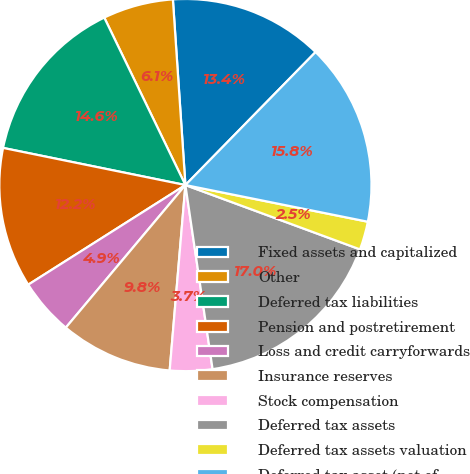Convert chart. <chart><loc_0><loc_0><loc_500><loc_500><pie_chart><fcel>Fixed assets and capitalized<fcel>Other<fcel>Deferred tax liabilities<fcel>Pension and postretirement<fcel>Loss and credit carryforwards<fcel>Insurance reserves<fcel>Stock compensation<fcel>Deferred tax assets<fcel>Deferred tax assets valuation<fcel>Deferred tax asset (net of<nl><fcel>13.4%<fcel>6.11%<fcel>14.62%<fcel>12.19%<fcel>4.9%<fcel>9.76%<fcel>3.68%<fcel>17.05%<fcel>2.46%<fcel>15.83%<nl></chart> 